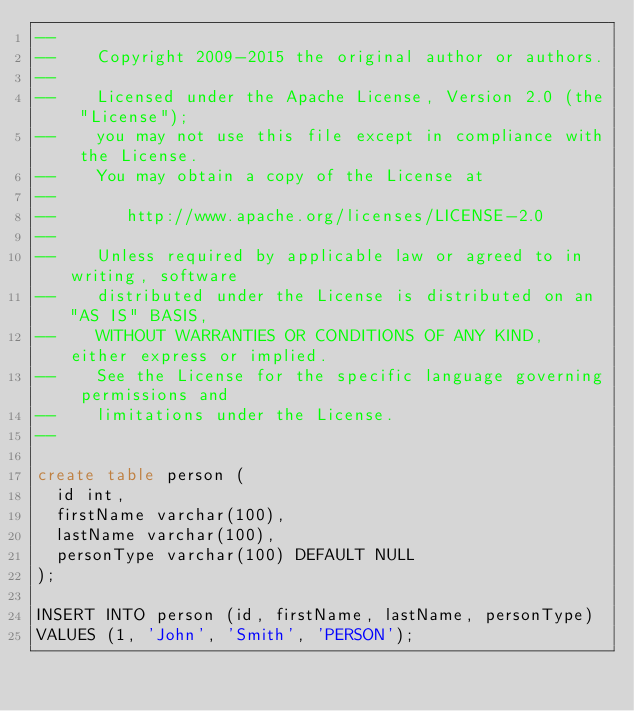<code> <loc_0><loc_0><loc_500><loc_500><_SQL_>--
--    Copyright 2009-2015 the original author or authors.
--
--    Licensed under the Apache License, Version 2.0 (the "License");
--    you may not use this file except in compliance with the License.
--    You may obtain a copy of the License at
--
--       http://www.apache.org/licenses/LICENSE-2.0
--
--    Unless required by applicable law or agreed to in writing, software
--    distributed under the License is distributed on an "AS IS" BASIS,
--    WITHOUT WARRANTIES OR CONDITIONS OF ANY KIND, either express or implied.
--    See the License for the specific language governing permissions and
--    limitations under the License.
--

create table person (
  id int,
  firstName varchar(100),
  lastName varchar(100),
  personType varchar(100) DEFAULT NULL
);

INSERT INTO person (id, firstName, lastName, personType)
VALUES (1, 'John', 'Smith', 'PERSON');
</code> 